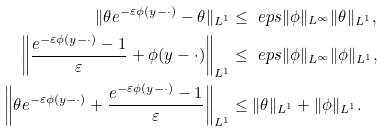<formula> <loc_0><loc_0><loc_500><loc_500>\| \theta e ^ { - \varepsilon \phi ( y - \cdot ) } - \theta \| _ { L ^ { 1 } } & \leq \ e p s \| \phi \| _ { L ^ { \infty } } \| \theta \| _ { L ^ { 1 } } , \\ \left \| \frac { e ^ { - \varepsilon \phi ( y - \cdot ) } - 1 } { \varepsilon } + \phi ( y - \cdot ) \right \| _ { L ^ { 1 } } & \leq \ e p s \| \phi \| _ { L ^ { \infty } } \| \phi \| _ { L ^ { 1 } } , \\ \left \| \theta e ^ { - \varepsilon \phi ( y - \cdot ) } + \frac { e ^ { - \varepsilon \phi ( y - \cdot ) } - 1 } { \varepsilon } \right \| _ { L ^ { 1 } } & \leq \| \theta \| _ { L ^ { 1 } } + \| \phi \| _ { L ^ { 1 } } .</formula> 